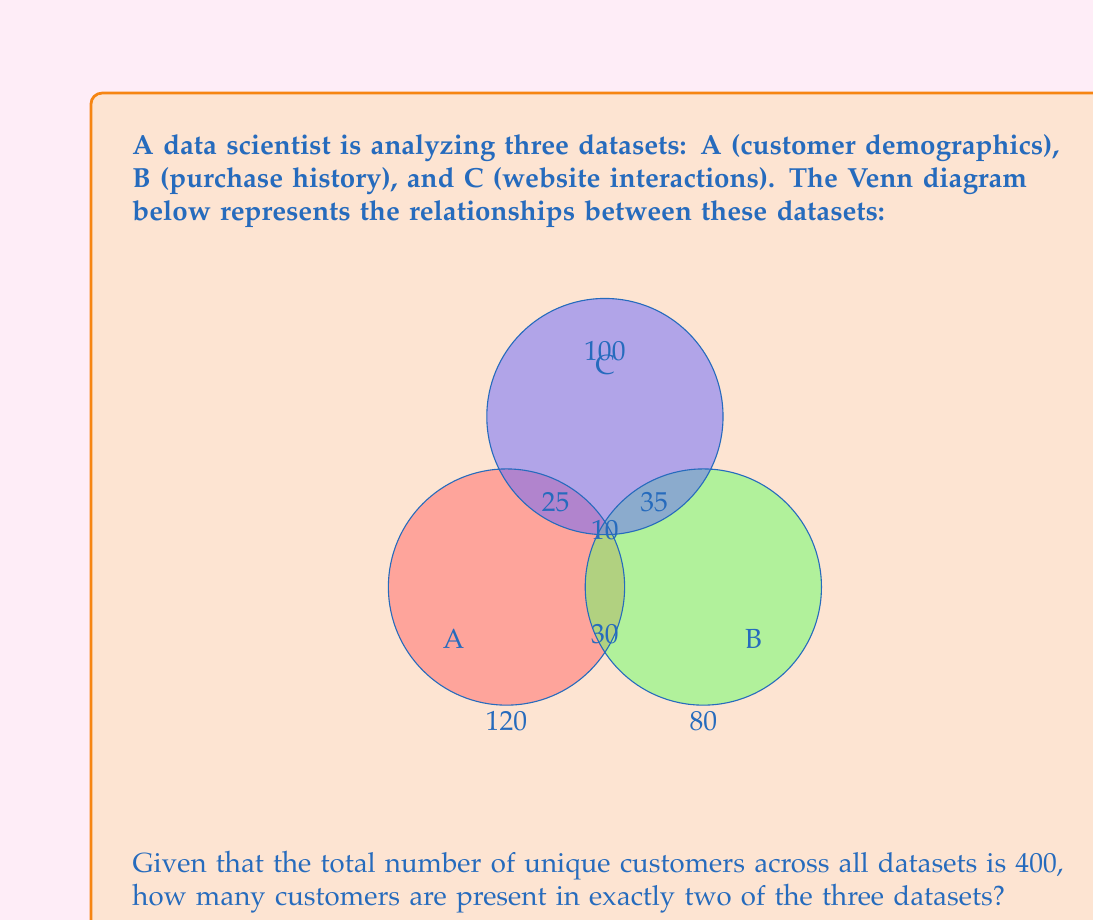Can you solve this math problem? To solve this problem, we'll use the concept of Venn diagrams and set theory. Let's break it down step by step:

1) First, let's identify the given information:
   - Total unique customers: 400
   - Customers in A only: 120
   - Customers in B only: 80
   - Customers in C only: 100
   - Customers in all three datasets (A ∩ B ∩ C): 10

2) Let's define variables for the regions we need to find:
   - Let $x$ be the number of customers in A ∩ B (but not in C)
   - Let $y$ be the number of customers in A ∩ C (but not in B)
   - Let $z$ be the number of customers in B ∩ C (but not in A)

3) We can now set up an equation based on the total number of customers:

   $$(120 + 80 + 100) + (x + y + z) + 10 = 400$$

4) Simplify:

   $$300 + (x + y + z) + 10 = 400$$
   $$x + y + z = 90$$

5) The question asks for the number of customers in exactly two datasets, which is the sum of $x$, $y$, and $z$.

Therefore, the number of customers in exactly two datasets is 90.
Answer: 90 